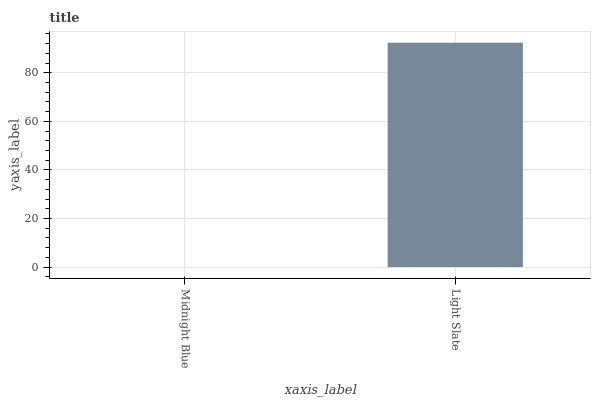Is Midnight Blue the minimum?
Answer yes or no. Yes. Is Light Slate the maximum?
Answer yes or no. Yes. Is Light Slate the minimum?
Answer yes or no. No. Is Light Slate greater than Midnight Blue?
Answer yes or no. Yes. Is Midnight Blue less than Light Slate?
Answer yes or no. Yes. Is Midnight Blue greater than Light Slate?
Answer yes or no. No. Is Light Slate less than Midnight Blue?
Answer yes or no. No. Is Light Slate the high median?
Answer yes or no. Yes. Is Midnight Blue the low median?
Answer yes or no. Yes. Is Midnight Blue the high median?
Answer yes or no. No. Is Light Slate the low median?
Answer yes or no. No. 